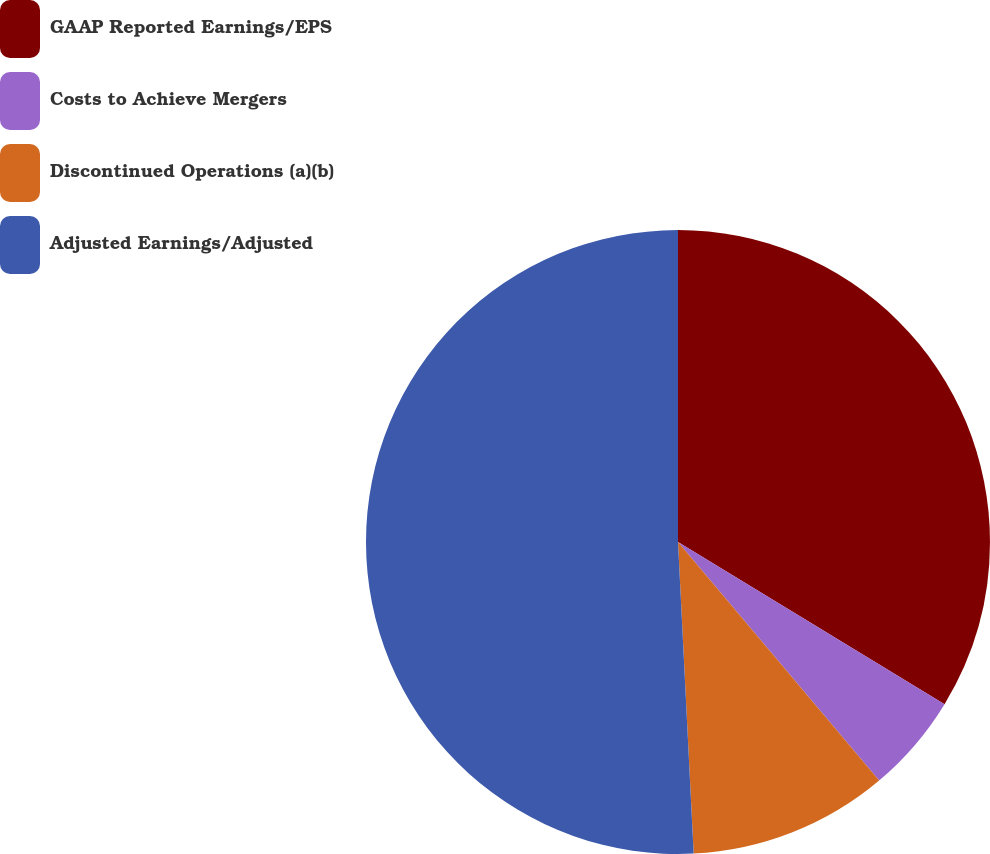Convert chart to OTSL. <chart><loc_0><loc_0><loc_500><loc_500><pie_chart><fcel>GAAP Reported Earnings/EPS<fcel>Costs to Achieve Mergers<fcel>Discontinued Operations (a)(b)<fcel>Adjusted Earnings/Adjusted<nl><fcel>33.7%<fcel>5.15%<fcel>10.35%<fcel>50.8%<nl></chart> 